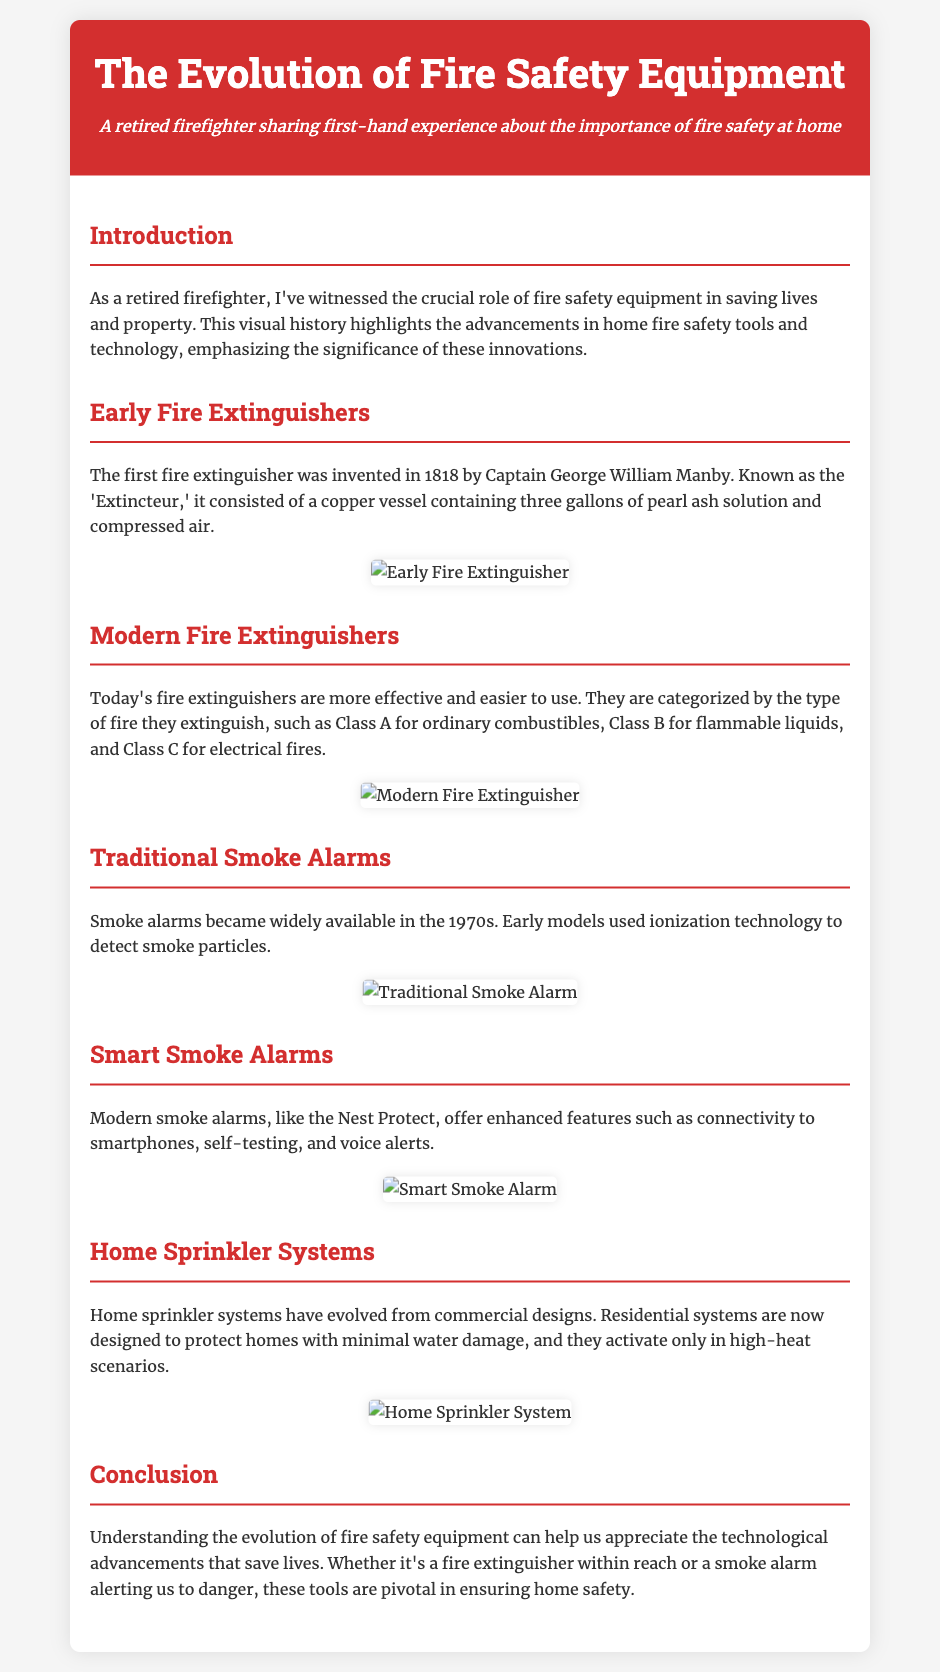What was the first fire extinguisher invented? The document states that the first fire extinguisher was invented in 1818 by Captain George William Manby and it was known as the 'Extincteur'.
Answer: Extincteur When did smoke alarms become widely available? According to the document, smoke alarms became widely available in the 1970s.
Answer: 1970s What type of fires does a Class B extinguisher combat? The document specifies that Class B extinguishers are for flammable liquids.
Answer: Flammable liquids What technology do modern smoke alarms like Nest Protect offer? The document mentions that modern smoke alarms offer features such as connectivity to smartphones, self-testing, and voice alerts.
Answer: Connectivity to smartphones How many gallons of solution did the first fire extinguisher contain? The document says the first fire extinguisher contained three gallons of pearl ash solution.
Answer: Three gallons What is a key feature of home sprinkler systems mentioned in the document? The document notes that residential sprinkler systems activate only in high-heat scenarios.
Answer: High-heat scenarios What invention is highlighted in the section discussing early fire extinguishers? The document highlights the 'Extincteur' in the section about early fire extinguishers.
Answer: Extincteur What aspect of fire safety does the conclusion emphasize? The conclusion emphasizes the appreciation of technological advancements that save lives.
Answer: Technological advancements 